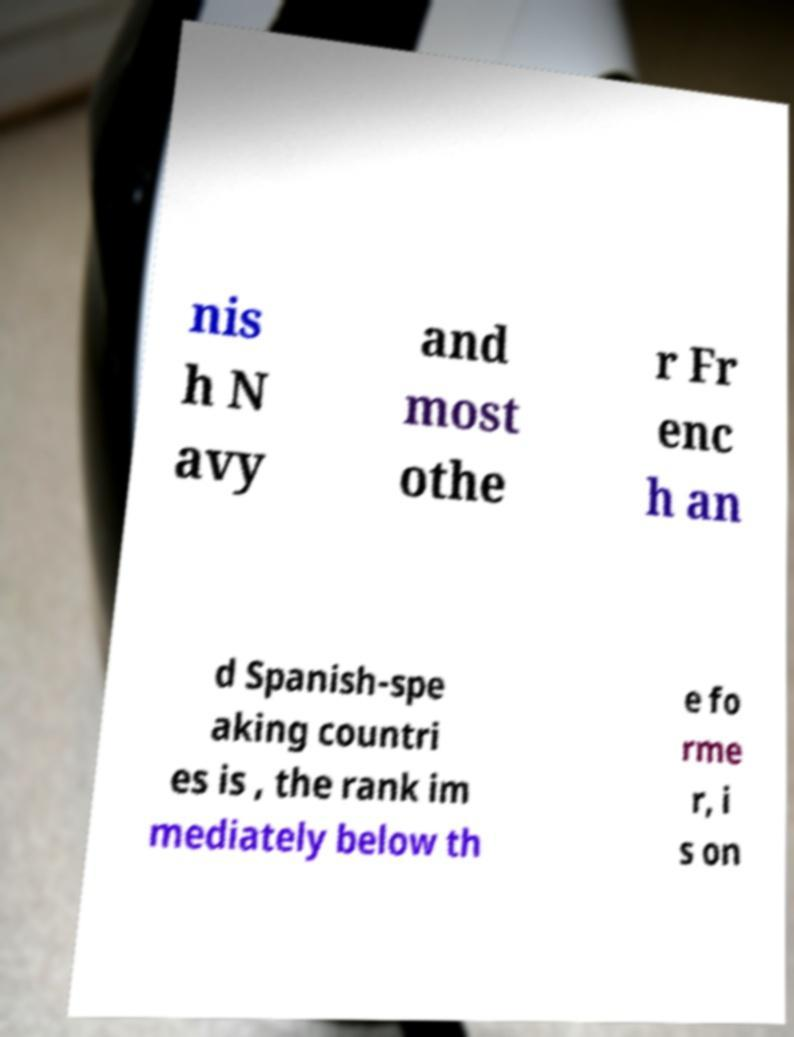For documentation purposes, I need the text within this image transcribed. Could you provide that? nis h N avy and most othe r Fr enc h an d Spanish-spe aking countri es is , the rank im mediately below th e fo rme r, i s on 